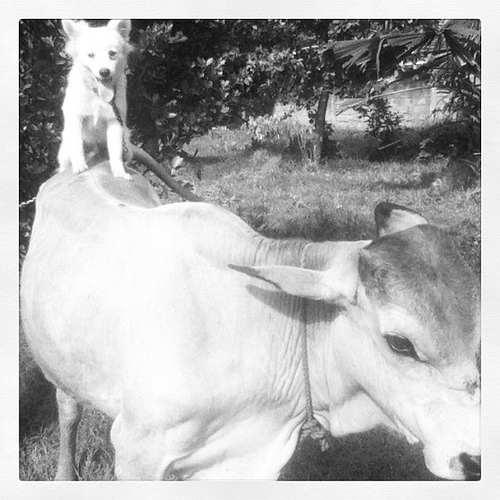What kind of dog is shown in the picture? The dog appears to be a small, light-colored breed, possibly a terrier mix, known for their energetic and friendly nature. 